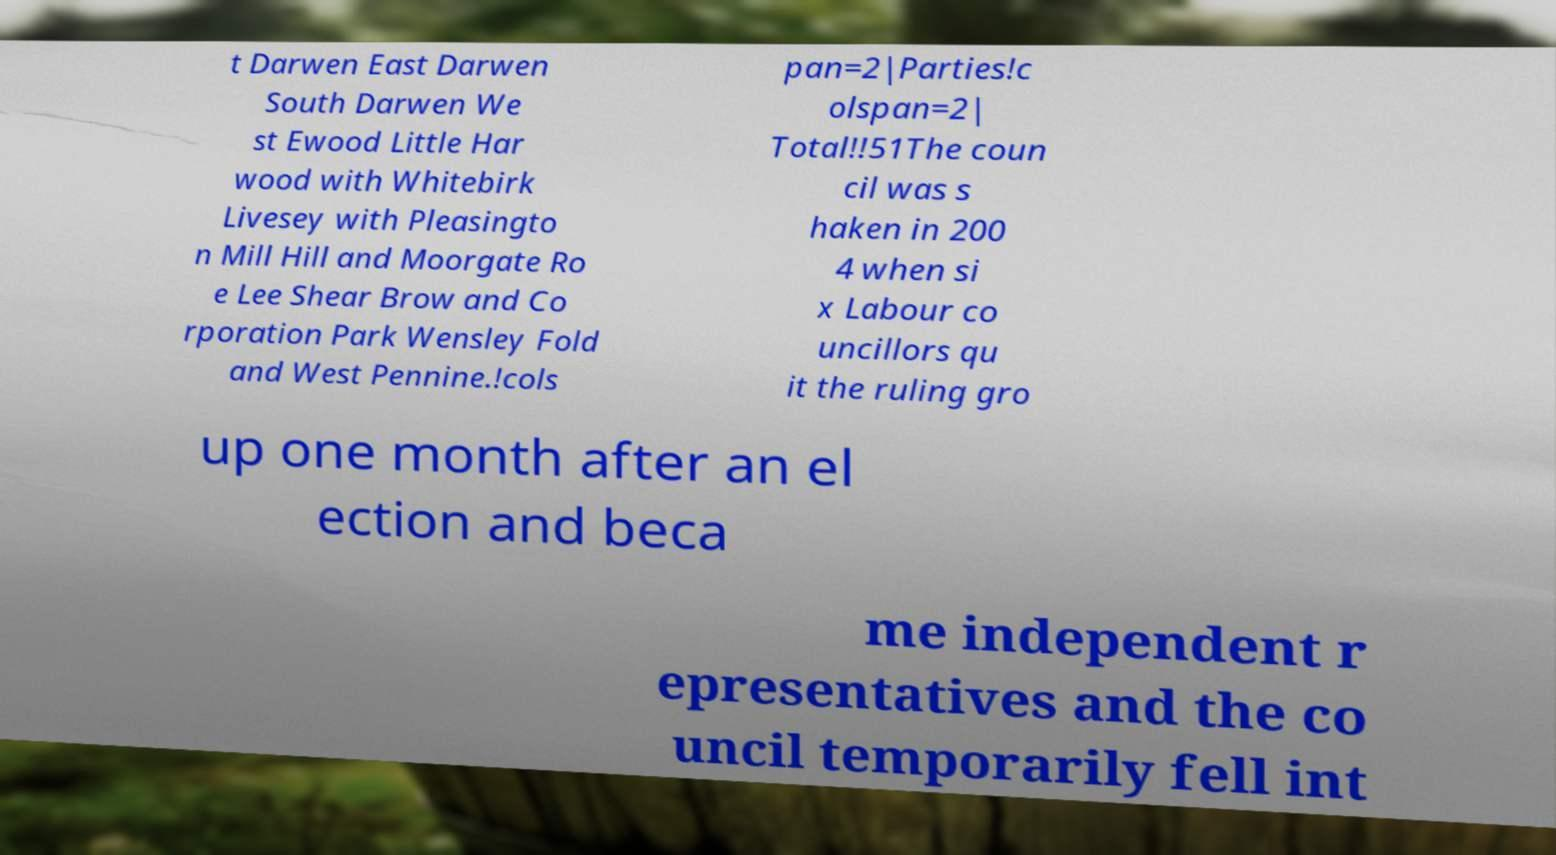There's text embedded in this image that I need extracted. Can you transcribe it verbatim? t Darwen East Darwen South Darwen We st Ewood Little Har wood with Whitebirk Livesey with Pleasingto n Mill Hill and Moorgate Ro e Lee Shear Brow and Co rporation Park Wensley Fold and West Pennine.!cols pan=2|Parties!c olspan=2| Total!!51The coun cil was s haken in 200 4 when si x Labour co uncillors qu it the ruling gro up one month after an el ection and beca me independent r epresentatives and the co uncil temporarily fell int 